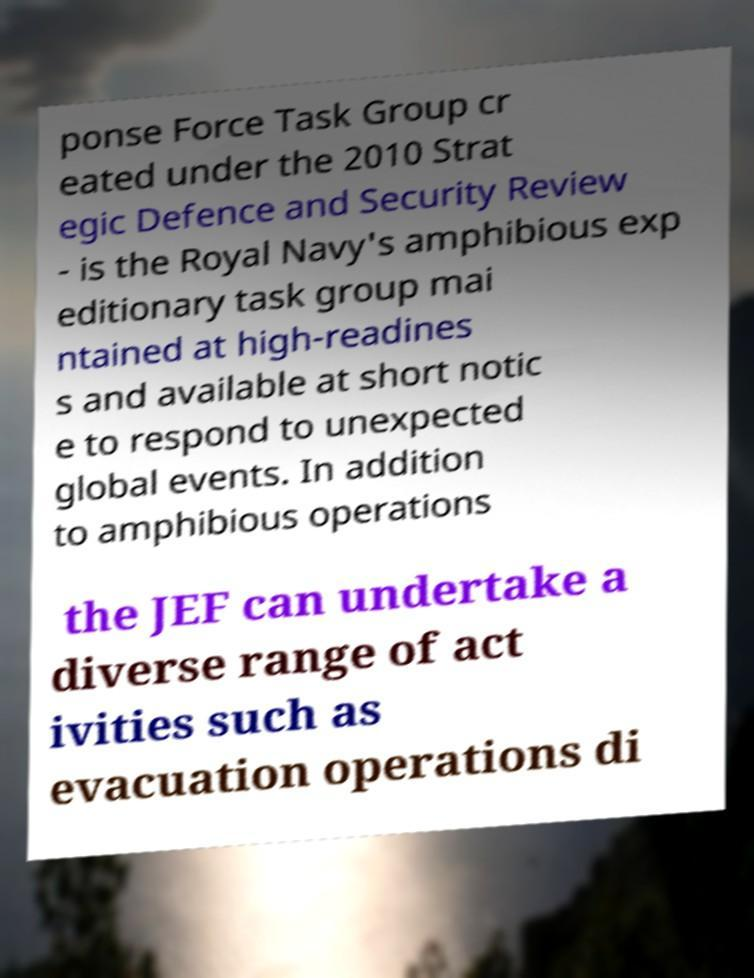Could you assist in decoding the text presented in this image and type it out clearly? ponse Force Task Group cr eated under the 2010 Strat egic Defence and Security Review - is the Royal Navy's amphibious exp editionary task group mai ntained at high-readines s and available at short notic e to respond to unexpected global events. In addition to amphibious operations the JEF can undertake a diverse range of act ivities such as evacuation operations di 